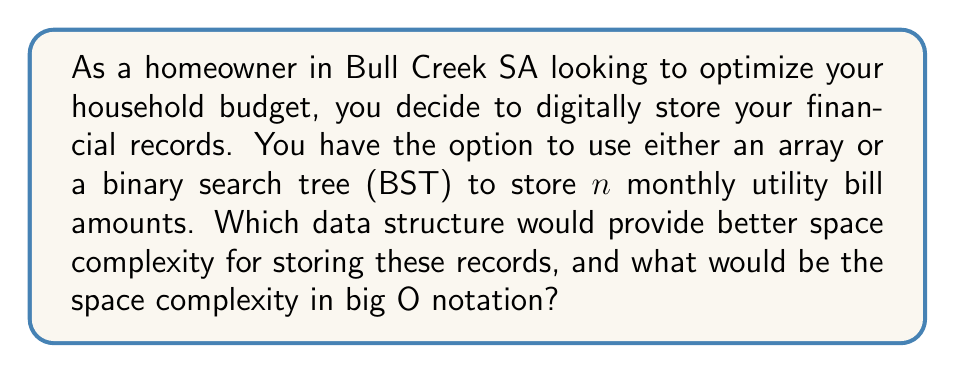Solve this math problem. To determine the better data structure for space complexity, let's analyze both options:

1. Array:
   - An array stores elements in contiguous memory locations.
   - For $n$ bill amounts, we need space for $n$ elements.
   - Each element (bill amount) can be stored as a floating-point number.
   - The space complexity for an array is $O(n)$.

2. Binary Search Tree (BST):
   - A BST stores elements in nodes, with each node containing the data and two pointers (left and right child).
   - For $n$ bill amounts, we need $n$ nodes.
   - Each node contains:
     a. The bill amount (floating-point number)
     b. Two pointers (left and right child)
   - The space required for each node is constant, regardless of the tree's size.
   - The space complexity for a BST is also $O(n)$.

Comparison:
Both data structures have a space complexity of $O(n)$. However, the constant factor differs:

- Array: $\text{Space} \approx n \times \text{size of float}$
- BST: $\text{Space} \approx n \times (\text{size of float} + 2 \times \text{size of pointer})$

The BST requires additional space for pointers, making it less space-efficient than the array for this specific use case.

Conclusion:
For storing monthly utility bill amounts, an array would provide better space efficiency, although both data structures have the same big O space complexity of $O(n)$.
Answer: The array provides better space efficiency. Both data structures have a space complexity of $O(n)$. 